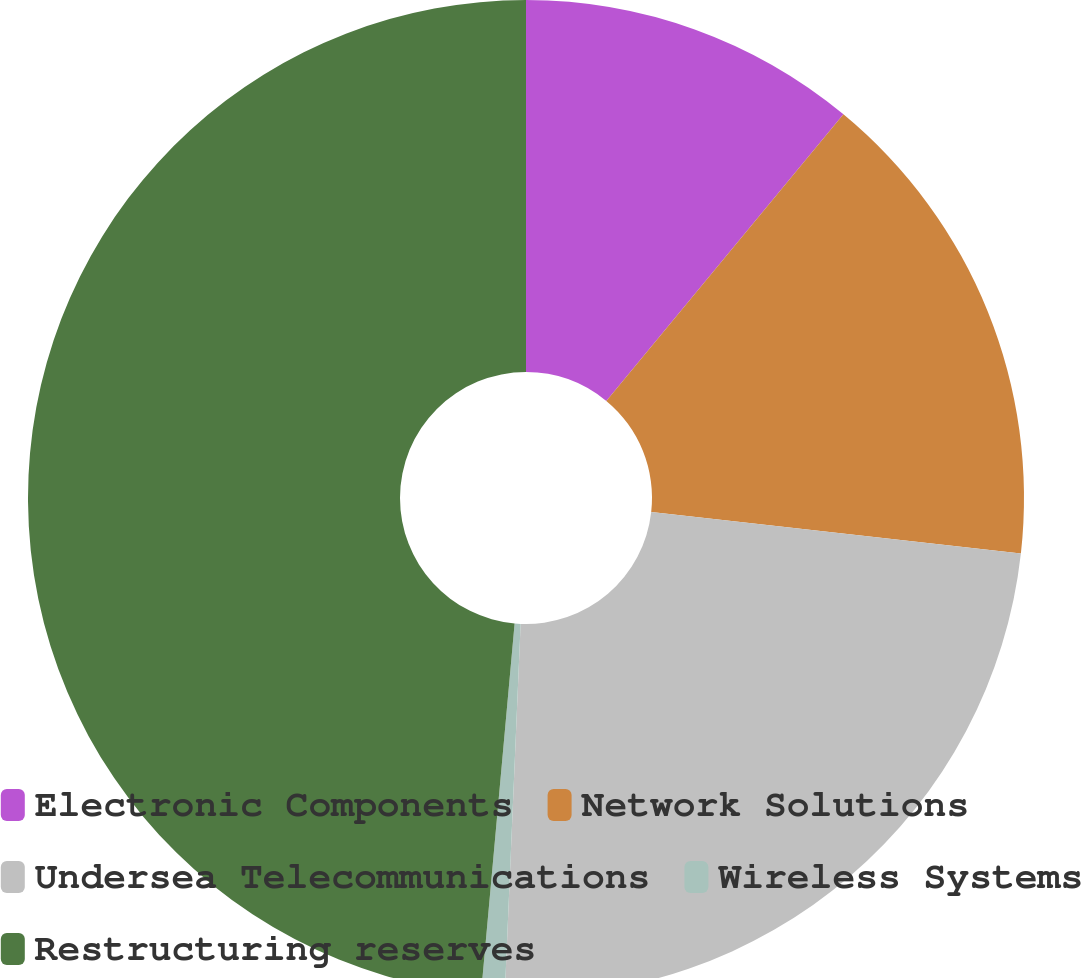Convert chart to OTSL. <chart><loc_0><loc_0><loc_500><loc_500><pie_chart><fcel>Electronic Components<fcel>Network Solutions<fcel>Undersea Telecommunications<fcel>Wireless Systems<fcel>Restructuring reserves<nl><fcel>11.0%<fcel>15.78%<fcel>23.9%<fcel>0.76%<fcel>48.56%<nl></chart> 